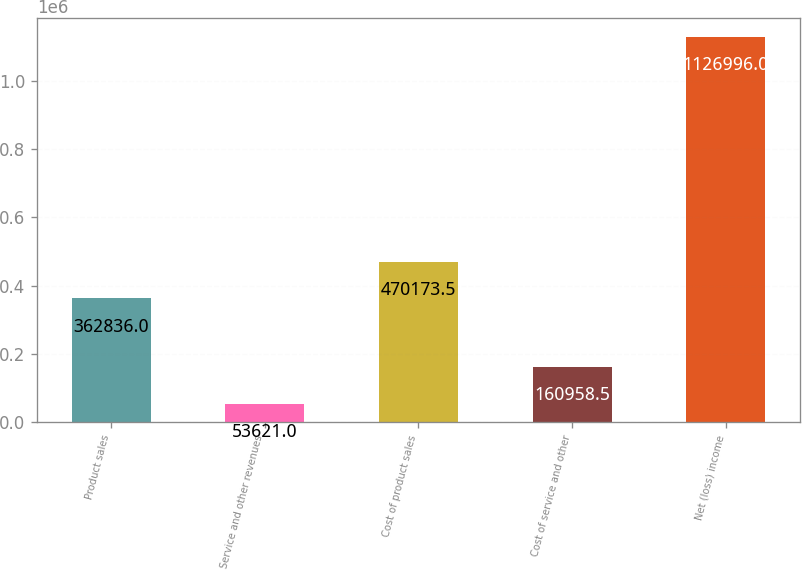<chart> <loc_0><loc_0><loc_500><loc_500><bar_chart><fcel>Product sales<fcel>Service and other revenues<fcel>Cost of product sales<fcel>Cost of service and other<fcel>Net (loss) income<nl><fcel>362836<fcel>53621<fcel>470174<fcel>160958<fcel>1.127e+06<nl></chart> 